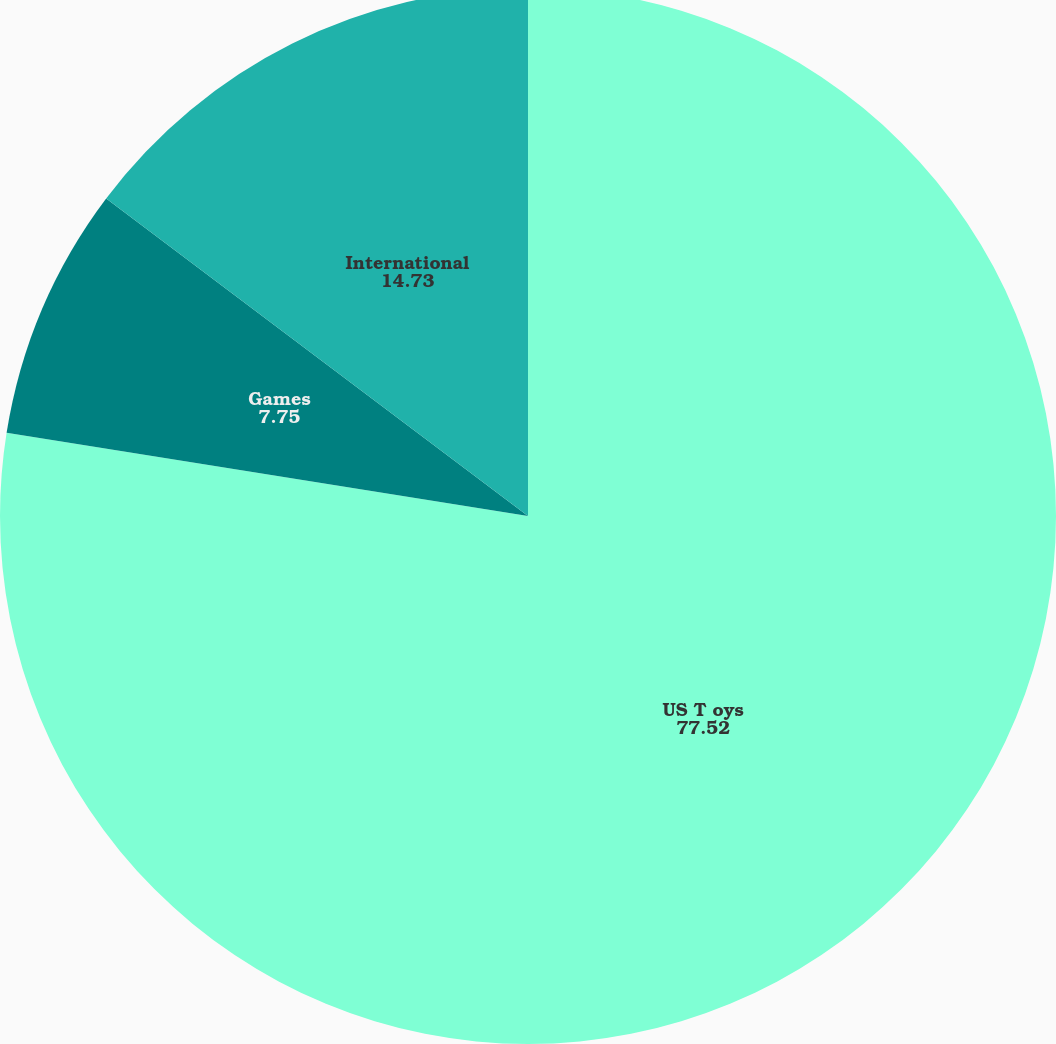Convert chart. <chart><loc_0><loc_0><loc_500><loc_500><pie_chart><fcel>US T oys<fcel>Games<fcel>International<nl><fcel>77.52%<fcel>7.75%<fcel>14.73%<nl></chart> 